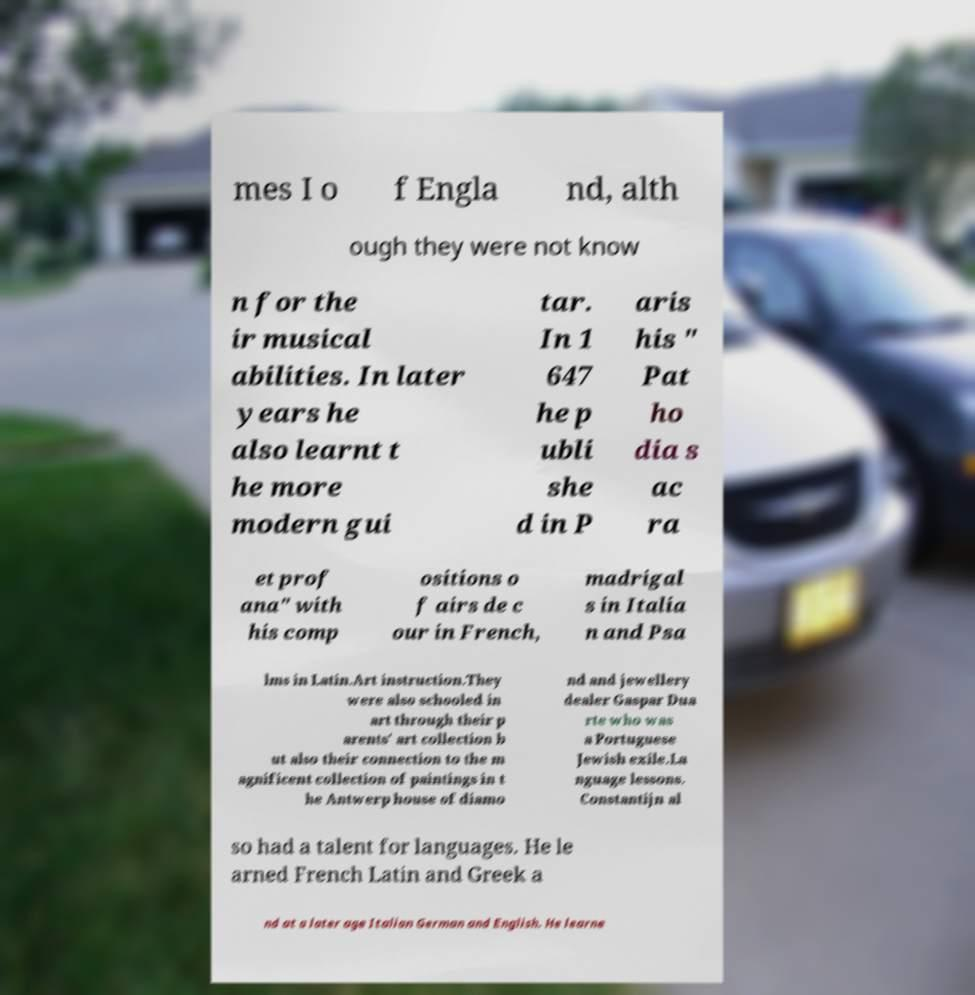There's text embedded in this image that I need extracted. Can you transcribe it verbatim? mes I o f Engla nd, alth ough they were not know n for the ir musical abilities. In later years he also learnt t he more modern gui tar. In 1 647 he p ubli she d in P aris his " Pat ho dia s ac ra et prof ana" with his comp ositions o f airs de c our in French, madrigal s in Italia n and Psa lms in Latin.Art instruction.They were also schooled in art through their p arents' art collection b ut also their connection to the m agnificent collection of paintings in t he Antwerp house of diamo nd and jewellery dealer Gaspar Dua rte who was a Portuguese Jewish exile.La nguage lessons. Constantijn al so had a talent for languages. He le arned French Latin and Greek a nd at a later age Italian German and English. He learne 